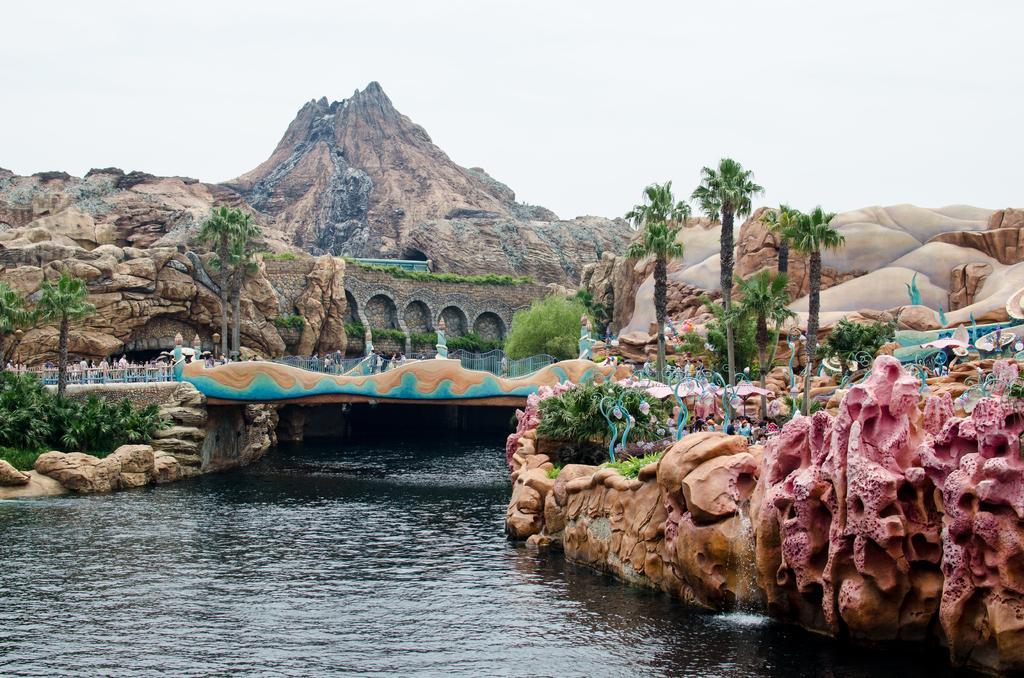In one or two sentences, can you explain what this image depicts? In this image I can see few trees, bridgewater, sky, rock and few colorful rocks. 